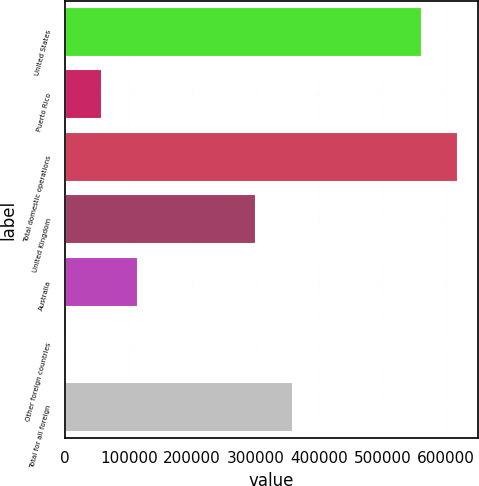<chart> <loc_0><loc_0><loc_500><loc_500><bar_chart><fcel>United States<fcel>Puerto Rico<fcel>Total domestic operations<fcel>United Kingdom<fcel>Australia<fcel>Other foreign countries<fcel>Total for all foreign<nl><fcel>561932<fcel>57490.3<fcel>619397<fcel>300794<fcel>114956<fcel>25<fcel>358259<nl></chart> 